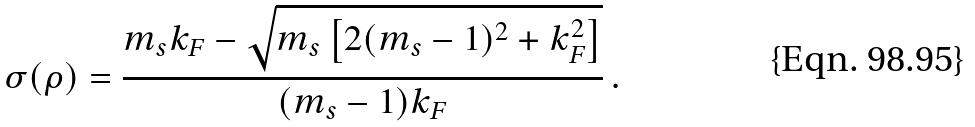Convert formula to latex. <formula><loc_0><loc_0><loc_500><loc_500>\sigma ( \rho ) = \frac { m _ { s } k _ { F } - \sqrt { m _ { s } \left [ 2 ( m _ { s } - 1 ) ^ { 2 } + k _ { F } ^ { 2 } \right ] } } { ( m _ { s } - 1 ) k _ { F } } \, .</formula> 